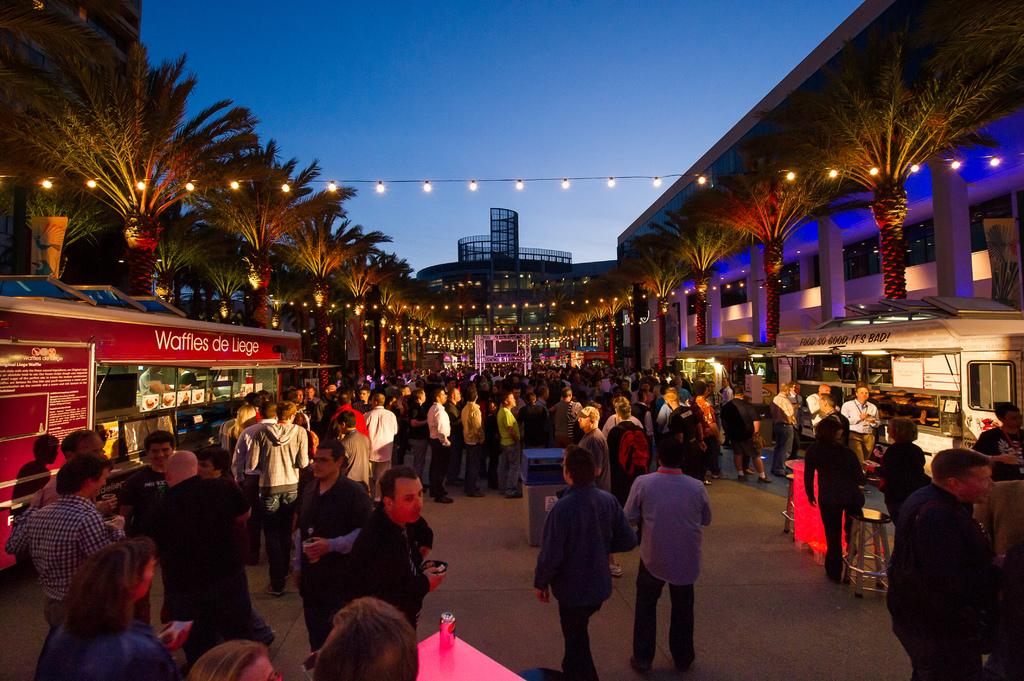What are the people in the image doing? The group of people is standing on the ground. What can be seen in the background of the image? There are buildings, trees, lights on wires, and the sky visible in the background of the image. What type of fruit can be seen hanging from the trees in the image? There is no fruit visible in the image; only trees are present in the background. 